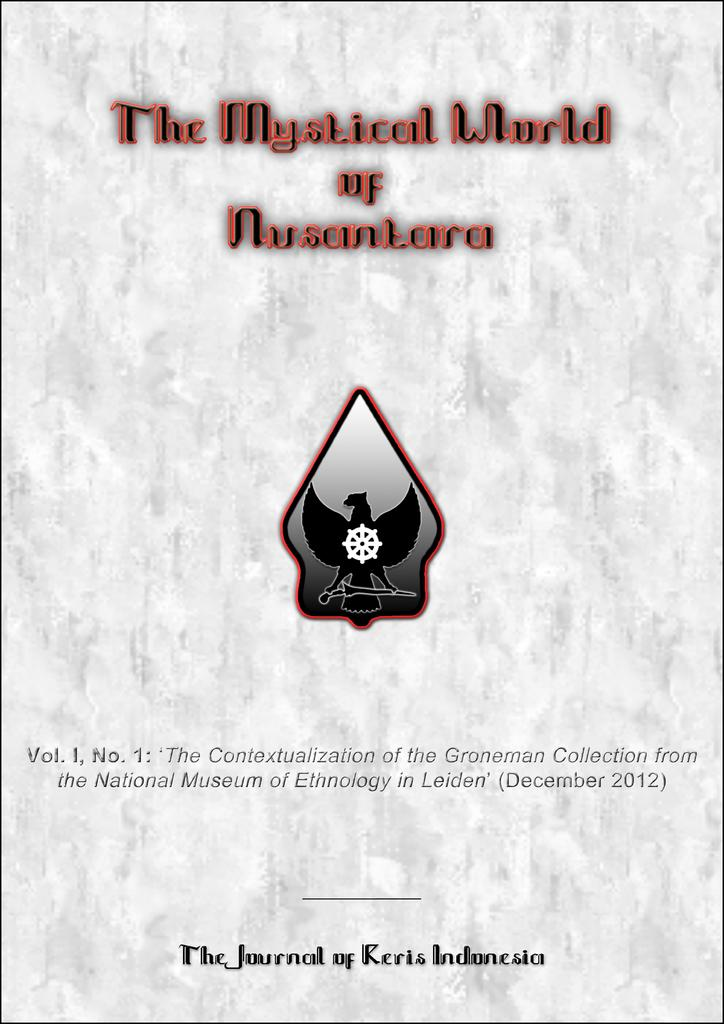<image>
Relay a brief, clear account of the picture shown. white book the mystical world of nusantara that has bird symbol on it 